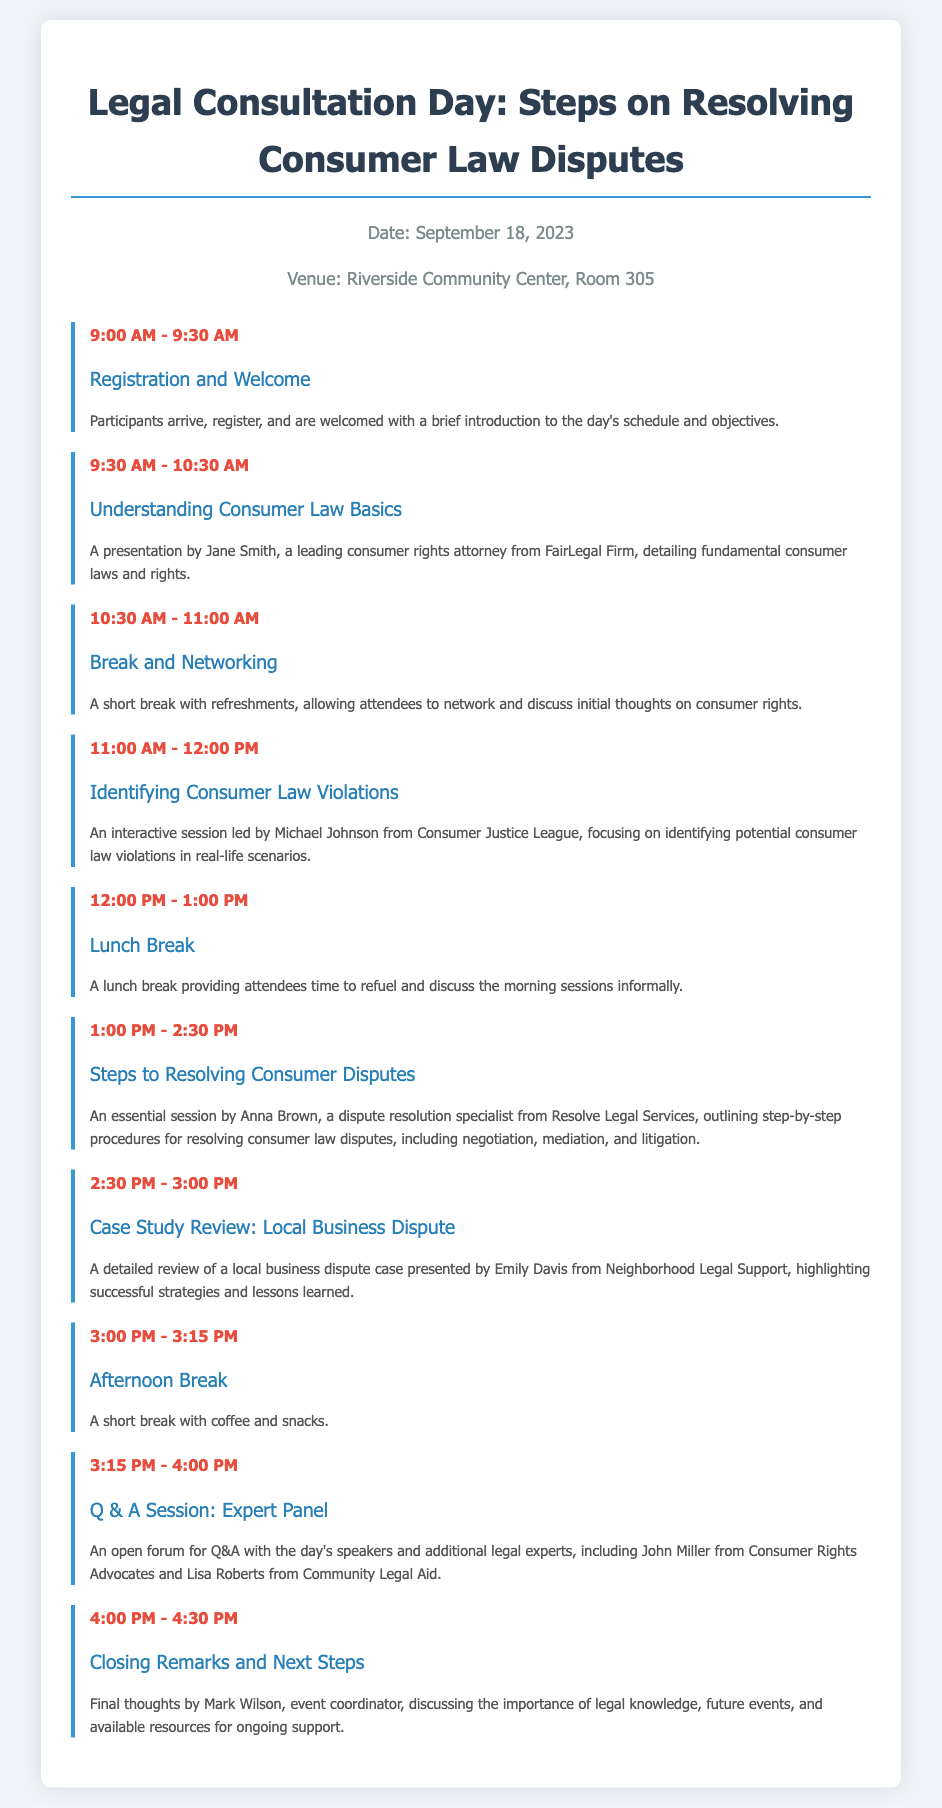What is the date of the event? The date of the event is mentioned in the event info section of the document.
Answer: September 18, 2023 What is the location of the venue? The venue is specified in the document's event info section.
Answer: Riverside Community Center, Room 305 Who is the speaker for "Understanding Consumer Law Basics"? The speaker's name is provided in the agenda for this specific session.
Answer: Jane Smith What time does the "Steps to Resolving Consumer Disputes" session start? The agenda clearly indicates the start time for this session.
Answer: 1:00 PM How long is the lunch break scheduled for? The agenda indicates the duration of the lunch break.
Answer: 1 hour What is the title of the afternoon Q&A session? The title is listed in the agenda under the relevant time slot.
Answer: Q & A Session: Expert Panel Which organization is Emily Davis affiliated with? The document states the affiliations of speakers beside their names during the agenda.
Answer: Neighborhood Legal Support What is the duration of the "Identifying Consumer Law Violations" session? The agenda outlines the start and end times, allowing calculation of the session duration.
Answer: 1 hour What are the refreshments provided during the afternoon break? The agenda mentions the type of refreshments offered during this specific break.
Answer: Coffee and snacks 